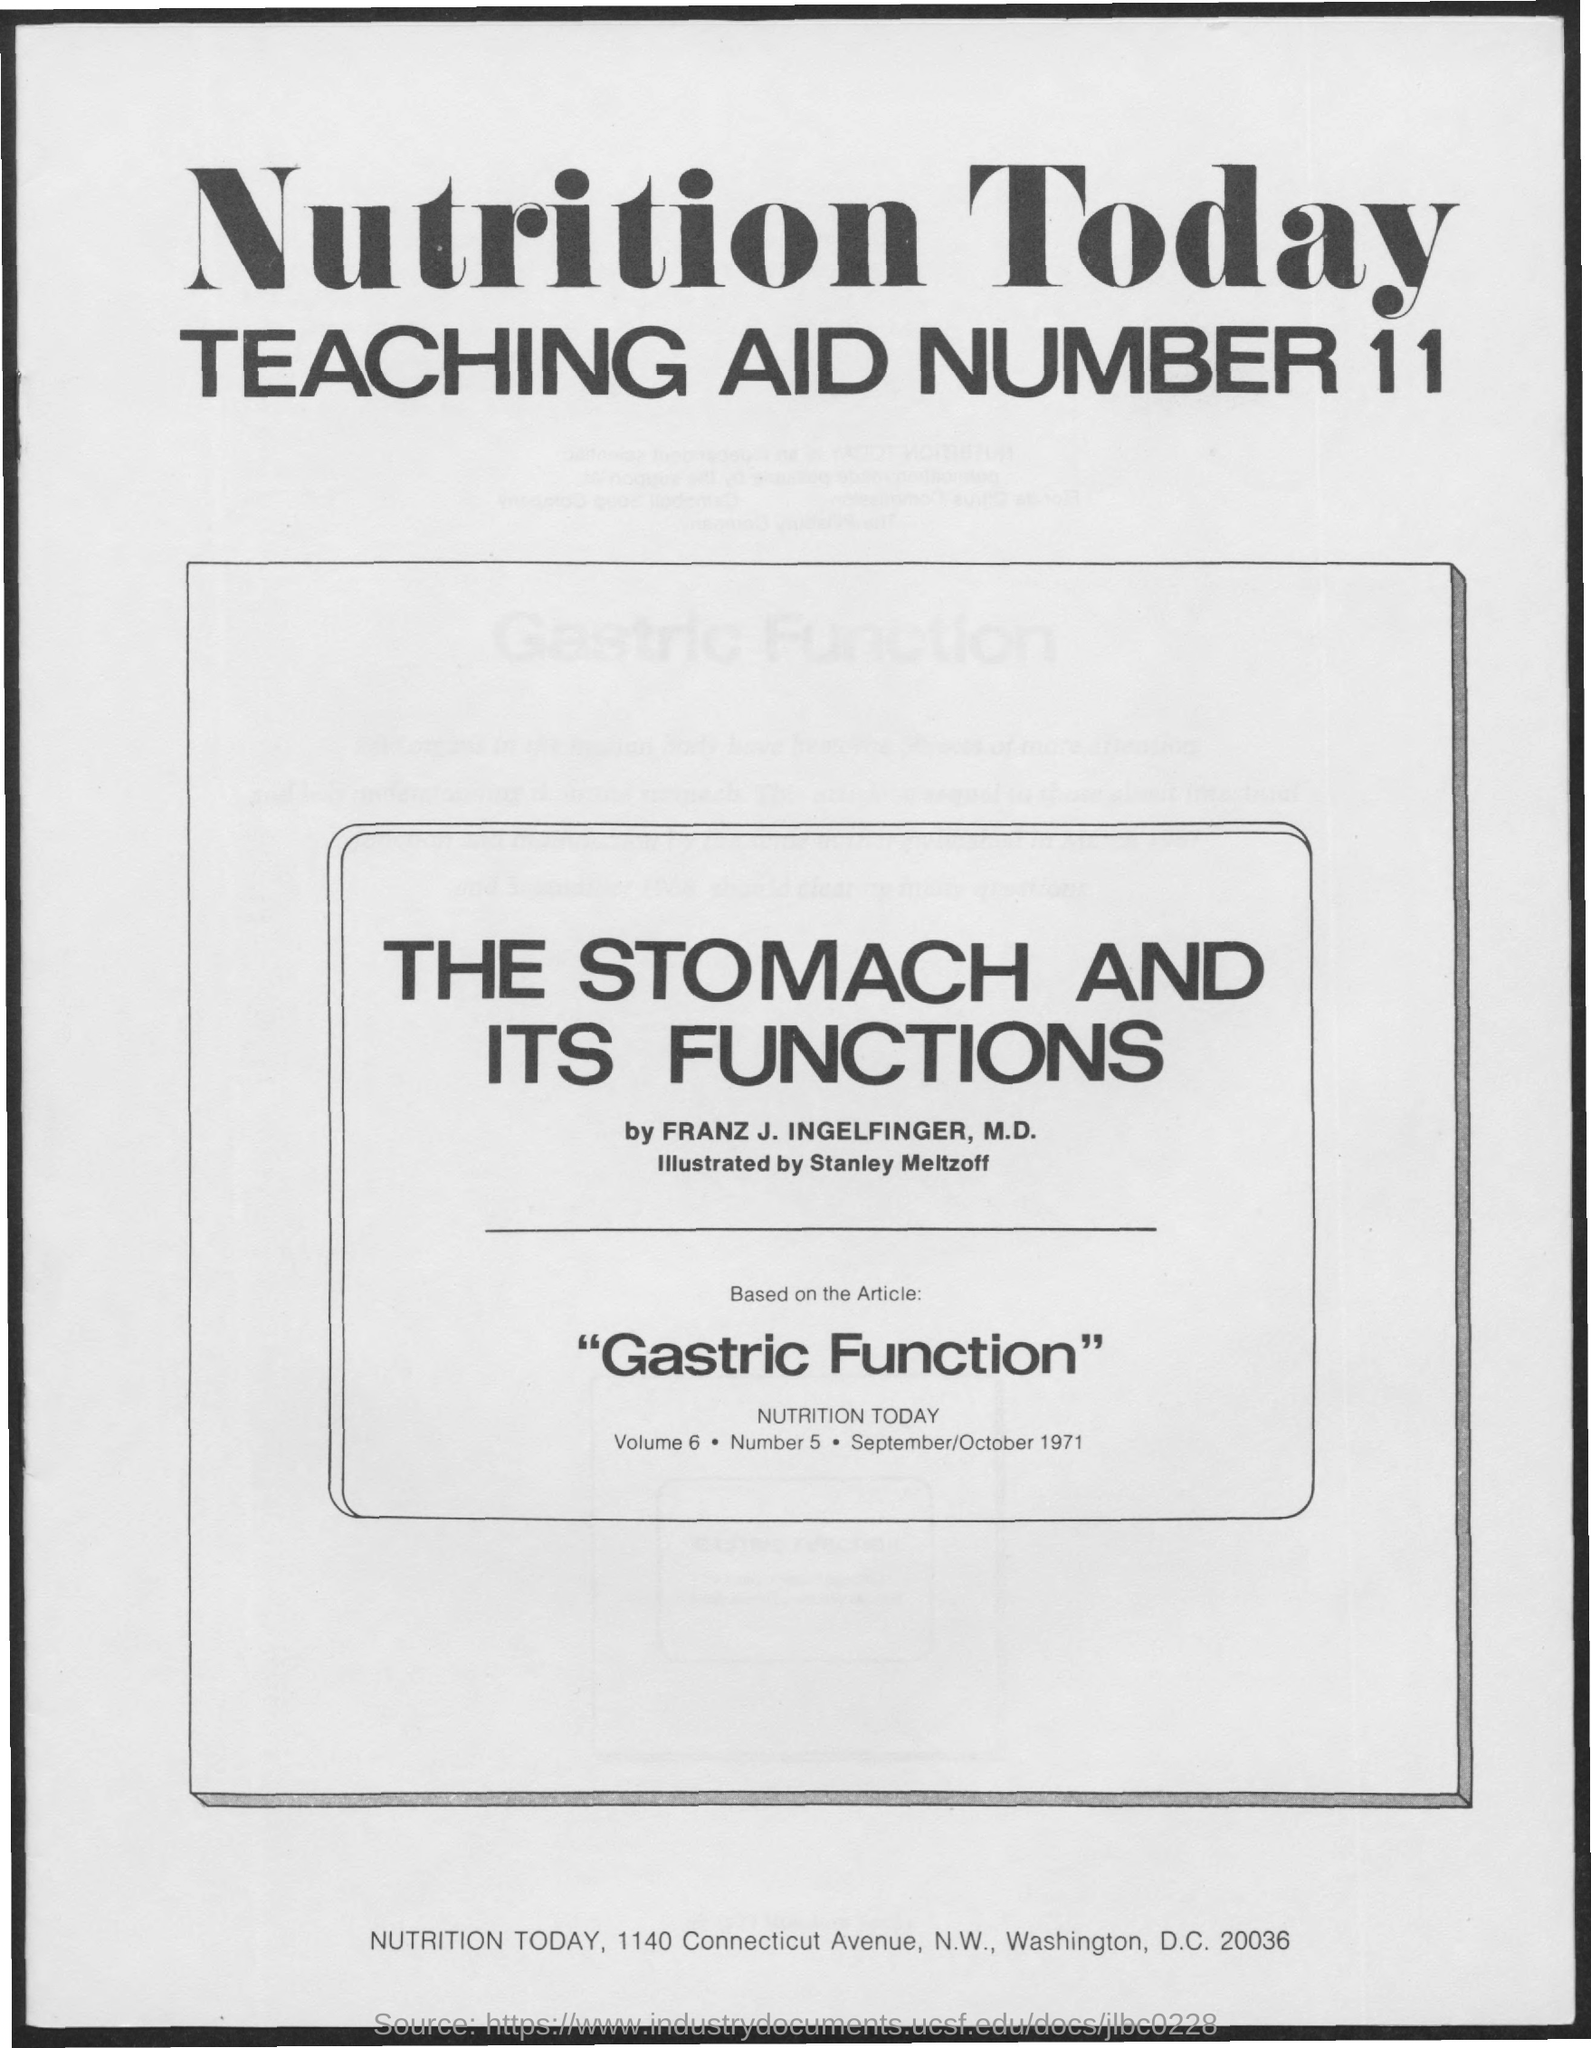Mention a couple of crucial points in this snapshot. The teaching aid number mentioned on the given page is 11. The teaching aid was based on the article titled "Gastric Function. The title of Teaching Aid Number 11, as mentioned in the given page, is "The Stomach and Its Functions". 